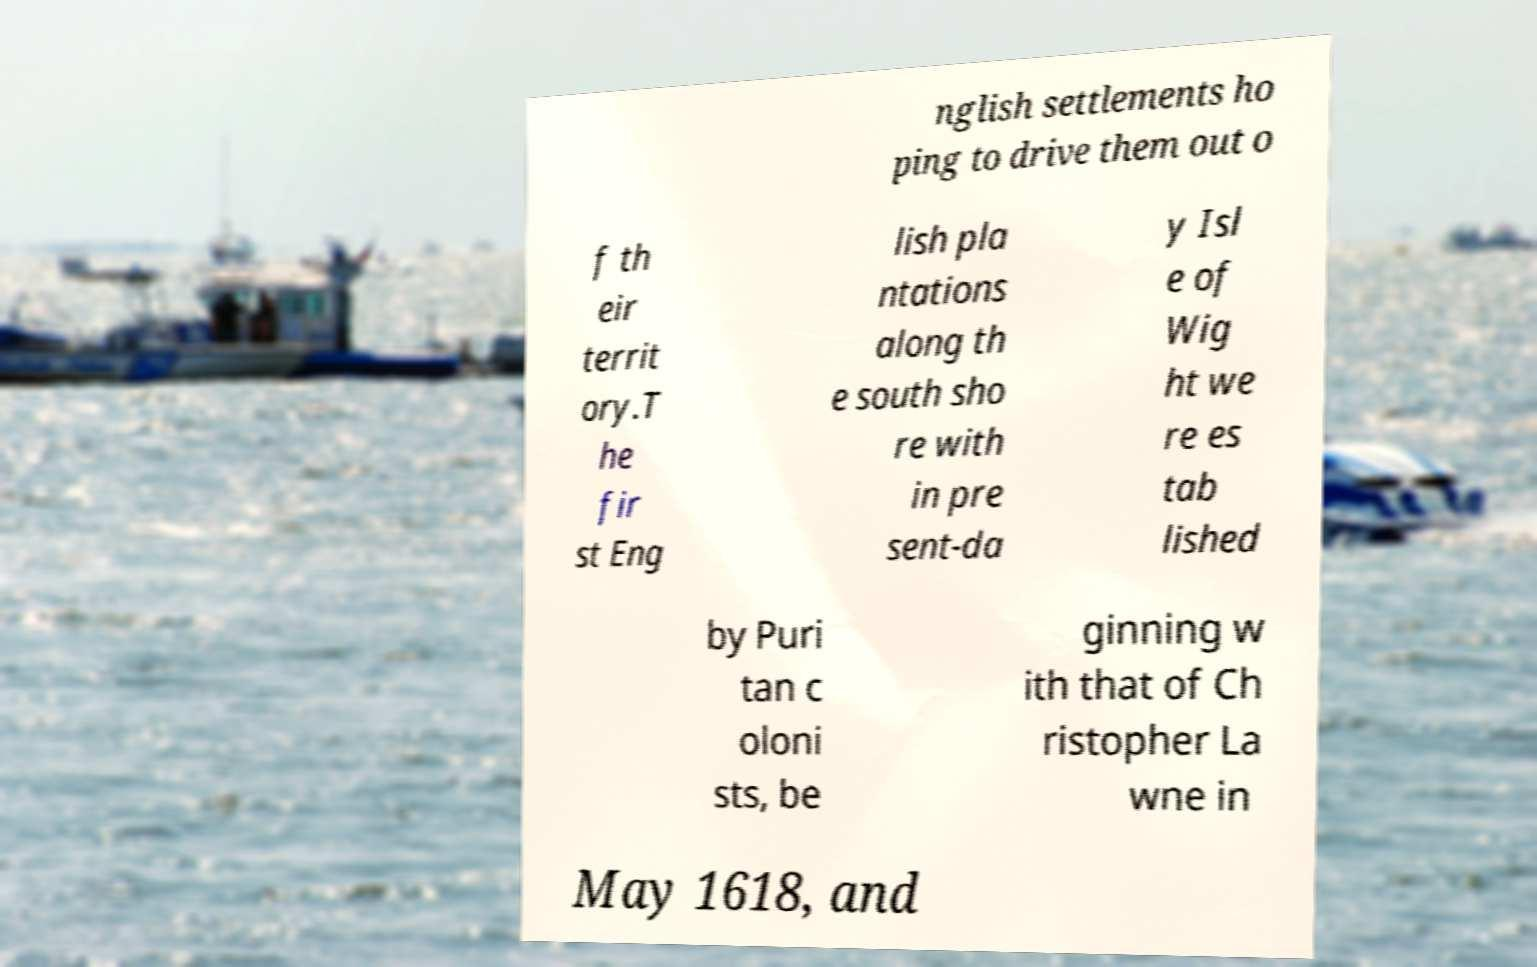I need the written content from this picture converted into text. Can you do that? nglish settlements ho ping to drive them out o f th eir territ ory.T he fir st Eng lish pla ntations along th e south sho re with in pre sent-da y Isl e of Wig ht we re es tab lished by Puri tan c oloni sts, be ginning w ith that of Ch ristopher La wne in May 1618, and 